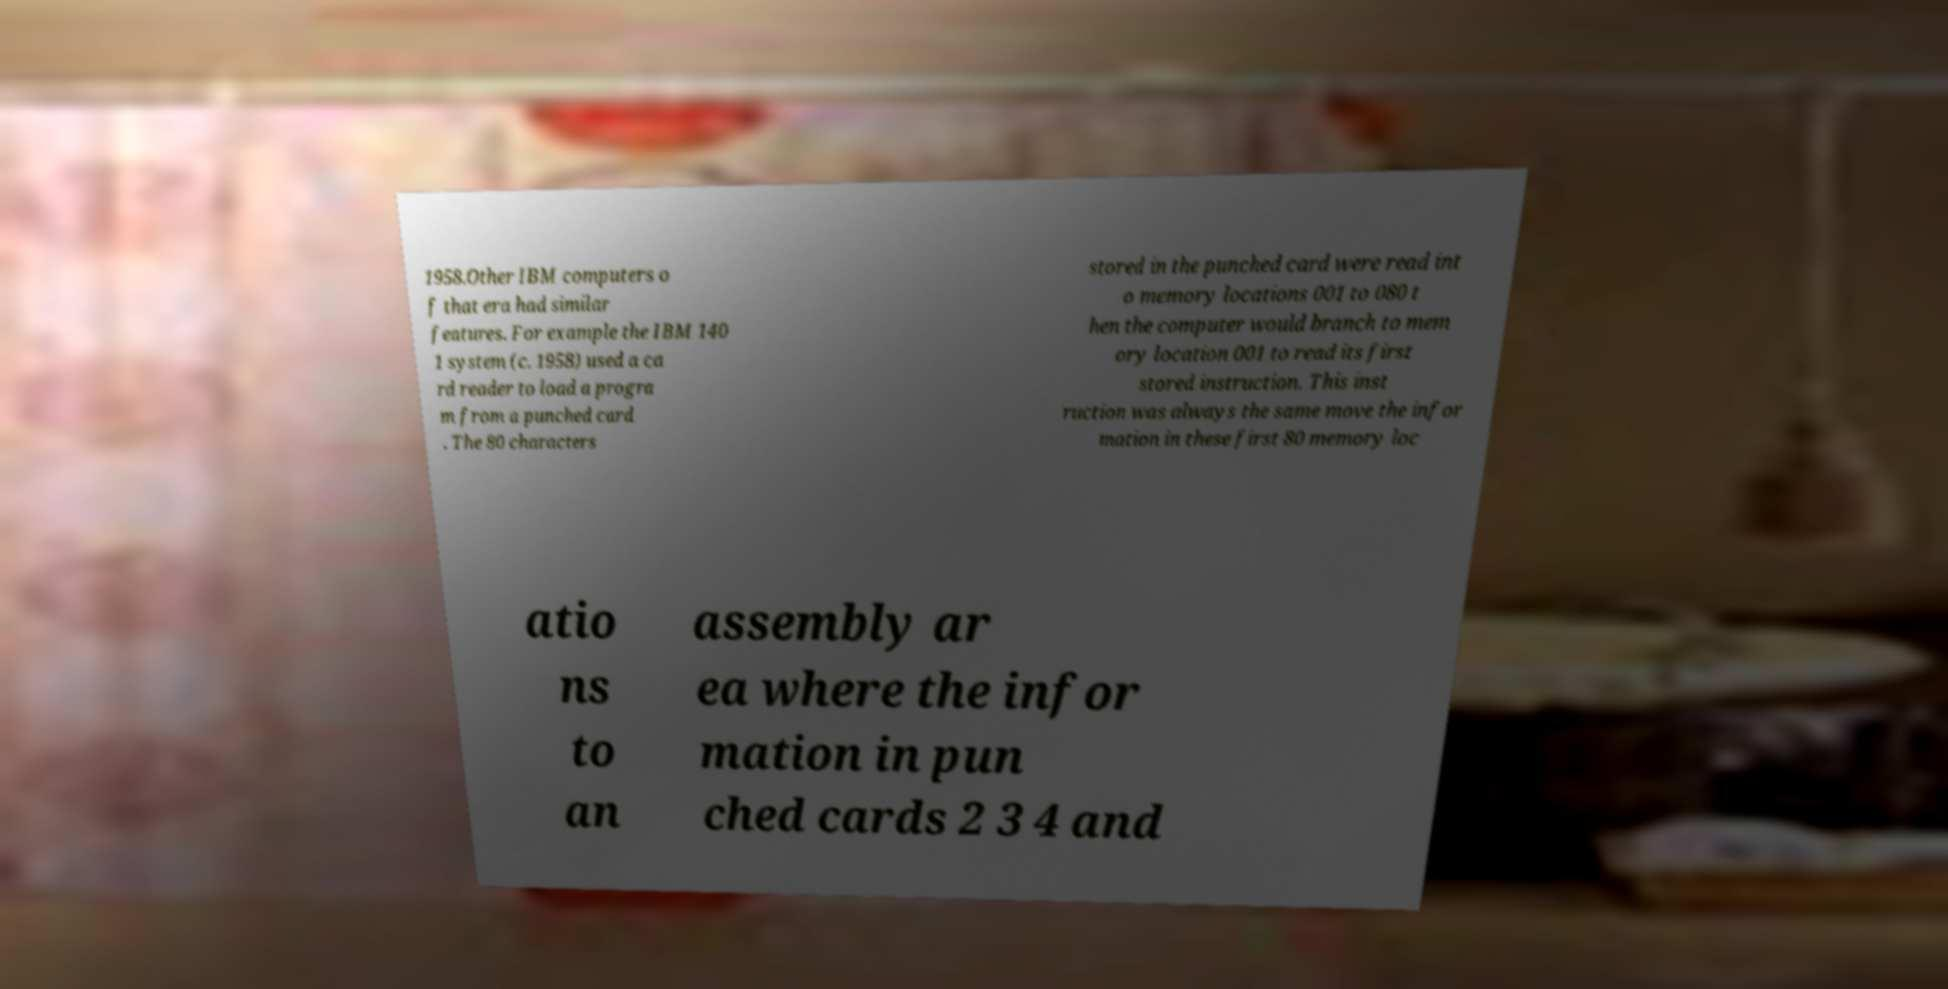For documentation purposes, I need the text within this image transcribed. Could you provide that? 1958.Other IBM computers o f that era had similar features. For example the IBM 140 1 system (c. 1958) used a ca rd reader to load a progra m from a punched card . The 80 characters stored in the punched card were read int o memory locations 001 to 080 t hen the computer would branch to mem ory location 001 to read its first stored instruction. This inst ruction was always the same move the infor mation in these first 80 memory loc atio ns to an assembly ar ea where the infor mation in pun ched cards 2 3 4 and 